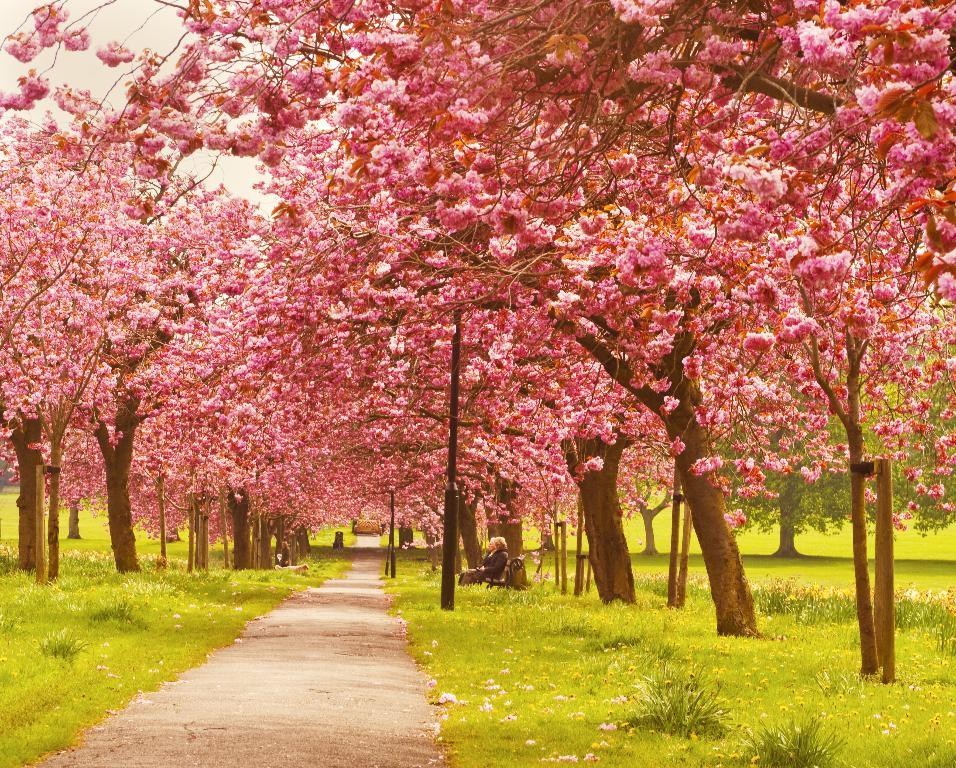What type of vegetation can be seen in the image? There are trees in the image. What is the lady doing in the image? The lady is sitting on a bench beneath the trees. What is in front of the lady? There is a path in front of the lady. Can you see a snake slithering on the path in the image? There is no snake present in the image. How many family members are visible in the image? The image only shows a lady sitting on a bench, so there is no family present. 